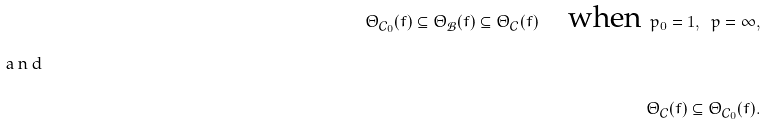<formula> <loc_0><loc_0><loc_500><loc_500>\Theta _ { \mathcal { C } _ { 0 } } ( f ) \subseteq \Theta _ { \mathcal { B } } ( f ) \subseteq \Theta _ { \mathcal { C } } ( f ) \quad \text {when} \ p _ { 0 } = 1 , \ p = \infty , \intertext { a n d } \Theta _ { \mathcal { C } } ( f ) \subseteq \Theta _ { \mathcal { C } _ { 0 } } ( f ) .</formula> 